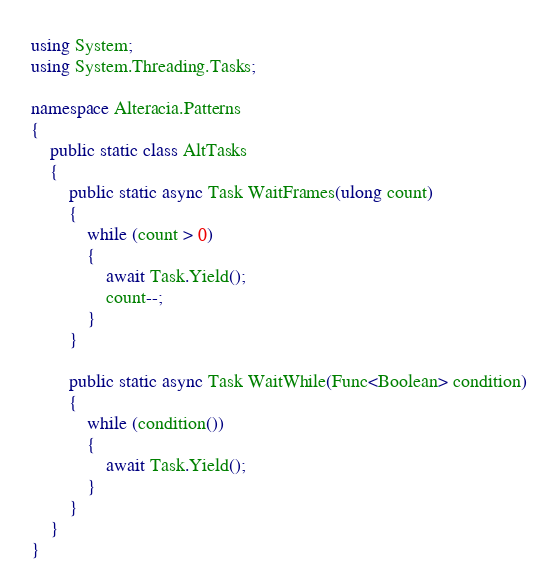<code> <loc_0><loc_0><loc_500><loc_500><_C#_>using System;
using System.Threading.Tasks;

namespace Alteracia.Patterns
{
    public static class AltTasks
    {
        public static async Task WaitFrames(ulong count)
        {
            while (count > 0)
            {
                await Task.Yield();
                count--;
            }
        }

        public static async Task WaitWhile(Func<Boolean> condition)
        {
            while (condition())
            {
                await Task.Yield();
            }
        }
    }
}</code> 